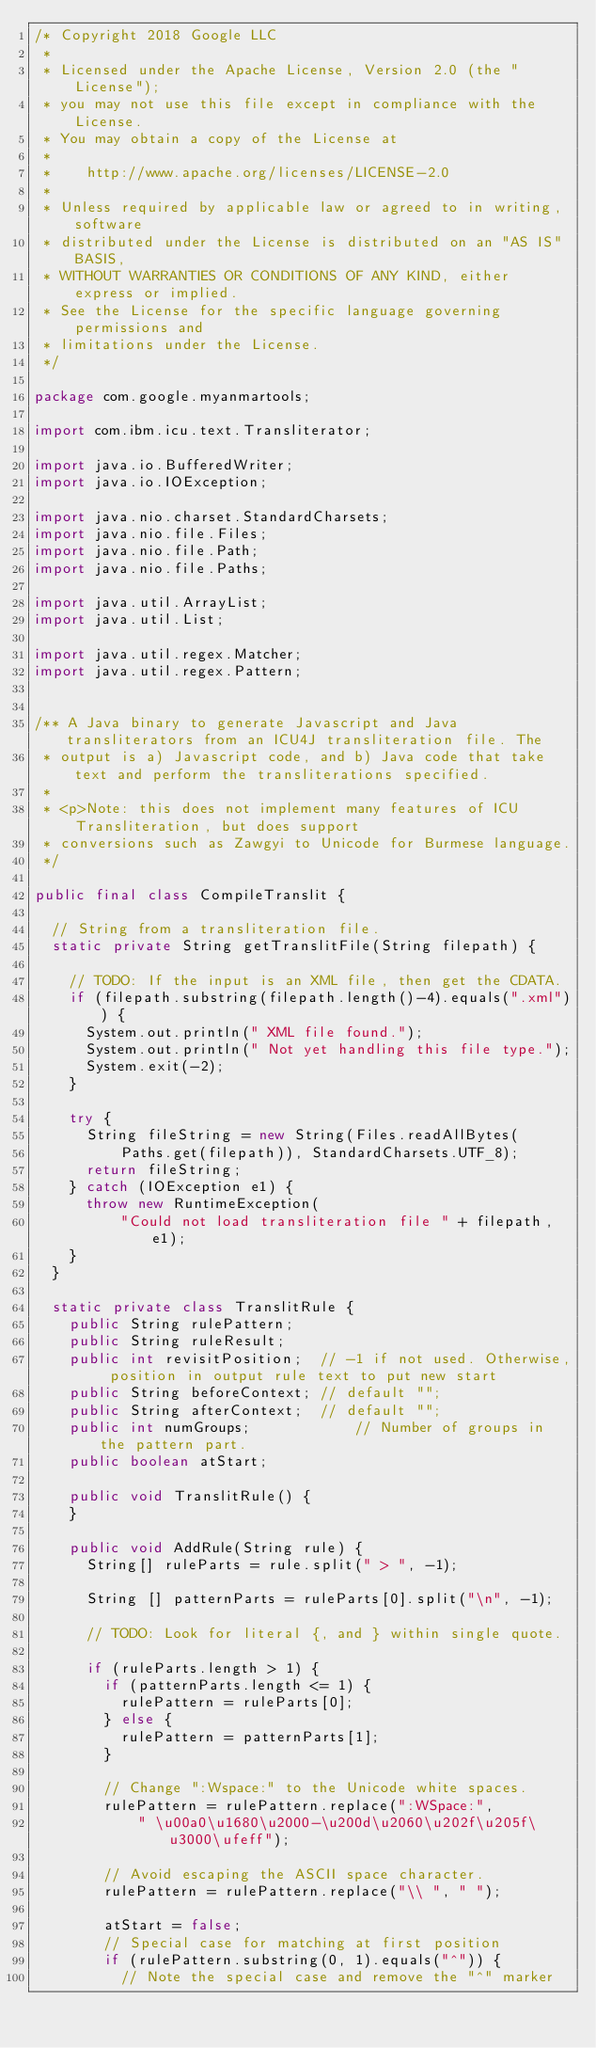Convert code to text. <code><loc_0><loc_0><loc_500><loc_500><_Java_>/* Copyright 2018 Google LLC
 *
 * Licensed under the Apache License, Version 2.0 (the "License");
 * you may not use this file except in compliance with the License.
 * You may obtain a copy of the License at
 *
 *    http://www.apache.org/licenses/LICENSE-2.0
 *
 * Unless required by applicable law or agreed to in writing, software
 * distributed under the License is distributed on an "AS IS" BASIS,
 * WITHOUT WARRANTIES OR CONDITIONS OF ANY KIND, either express or implied.
 * See the License for the specific language governing permissions and
 * limitations under the License.
 */

package com.google.myanmartools;

import com.ibm.icu.text.Transliterator;

import java.io.BufferedWriter;
import java.io.IOException;

import java.nio.charset.StandardCharsets;
import java.nio.file.Files;
import java.nio.file.Path;
import java.nio.file.Paths;

import java.util.ArrayList;
import java.util.List;

import java.util.regex.Matcher;
import java.util.regex.Pattern;


/** A Java binary to generate Javascript and Java transliterators from an ICU4J transliteration file. The
 * output is a) Javascript code, and b) Java code that take text and perform the transliterations specified.
 *
 * <p>Note: this does not implement many features of ICU Transliteration, but does support
 * conversions such as Zawgyi to Unicode for Burmese language.
 */

public final class CompileTranslit {

  // String from a transliteration file.
  static private String getTranslitFile(String filepath) {

    // TODO: If the input is an XML file, then get the CDATA.
    if (filepath.substring(filepath.length()-4).equals(".xml")) {
      System.out.println(" XML file found.");
      System.out.println(" Not yet handling this file type.");
      System.exit(-2);
    }

    try {
      String fileString = new String(Files.readAllBytes(
          Paths.get(filepath)), StandardCharsets.UTF_8);
      return fileString;
    } catch (IOException e1) {
      throw new RuntimeException(
          "Could not load transliteration file " + filepath, e1);
    }
  }

  static private class TranslitRule {
    public String rulePattern;
    public String ruleResult;
    public int revisitPosition;  // -1 if not used. Otherwise, position in output rule text to put new start
    public String beforeContext; // default "";
    public String afterContext;  // default "";
    public int numGroups;            // Number of groups in the pattern part.
    public boolean atStart;

    public void TranslitRule() {
    }

    public void AddRule(String rule) {
      String[] ruleParts = rule.split(" > ", -1);

      String [] patternParts = ruleParts[0].split("\n", -1);

      // TODO: Look for literal {, and } within single quote.

      if (ruleParts.length > 1) {
        if (patternParts.length <= 1) {
          rulePattern = ruleParts[0];
        } else {
          rulePattern = patternParts[1];
        }

        // Change ":Wspace:" to the Unicode white spaces.
        rulePattern = rulePattern.replace(":WSpace:",
            " \u00a0\u1680\u2000-\u200d\u2060\u202f\u205f\u3000\ufeff");

        // Avoid escaping the ASCII space character.
        rulePattern = rulePattern.replace("\\ ", " ");

        atStart = false;
        // Special case for matching at first position
        if (rulePattern.substring(0, 1).equals("^")) {
          // Note the special case and remove the "^" marker</code> 